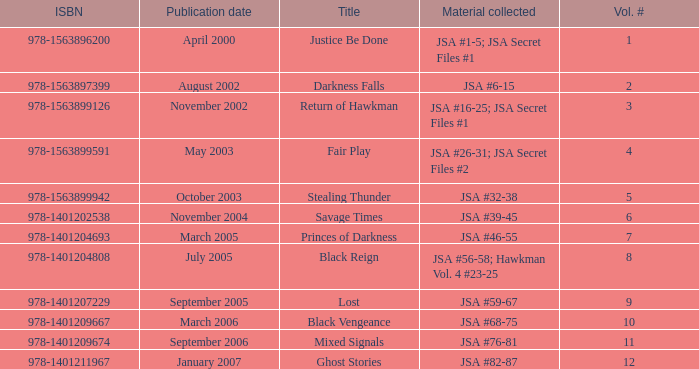How many Volume Numbers have the title of Darkness Falls? 2.0. 